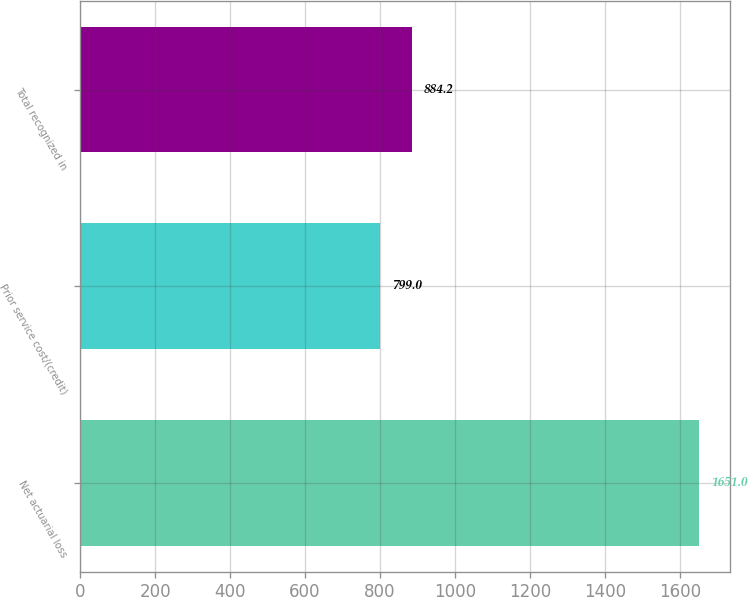Convert chart to OTSL. <chart><loc_0><loc_0><loc_500><loc_500><bar_chart><fcel>Net actuarial loss<fcel>Prior service cost/(credit)<fcel>Total recognized in<nl><fcel>1651<fcel>799<fcel>884.2<nl></chart> 